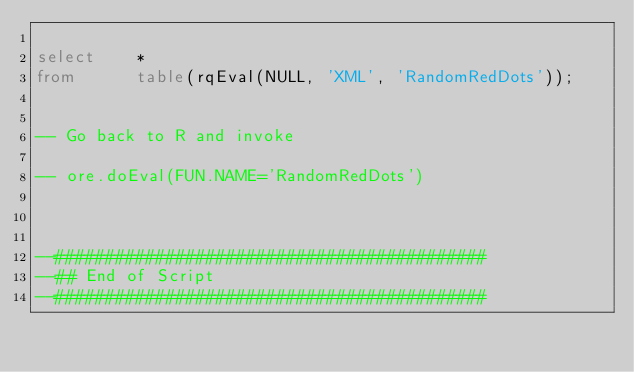Convert code to text. <code><loc_0><loc_0><loc_500><loc_500><_SQL_>
select    *
from      table(rqEval(NULL, 'XML', 'RandomRedDots'));


-- Go back to R and invoke

-- ore.doEval(FUN.NAME='RandomRedDots')
 


--###########################################
--## End of Script
--###########################################

 </code> 